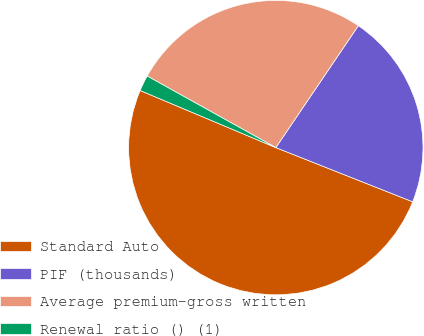Convert chart. <chart><loc_0><loc_0><loc_500><loc_500><pie_chart><fcel>Standard Auto<fcel>PIF (thousands)<fcel>Average premium-gross written<fcel>Renewal ratio () (1)<nl><fcel>50.34%<fcel>21.53%<fcel>26.39%<fcel>1.74%<nl></chart> 